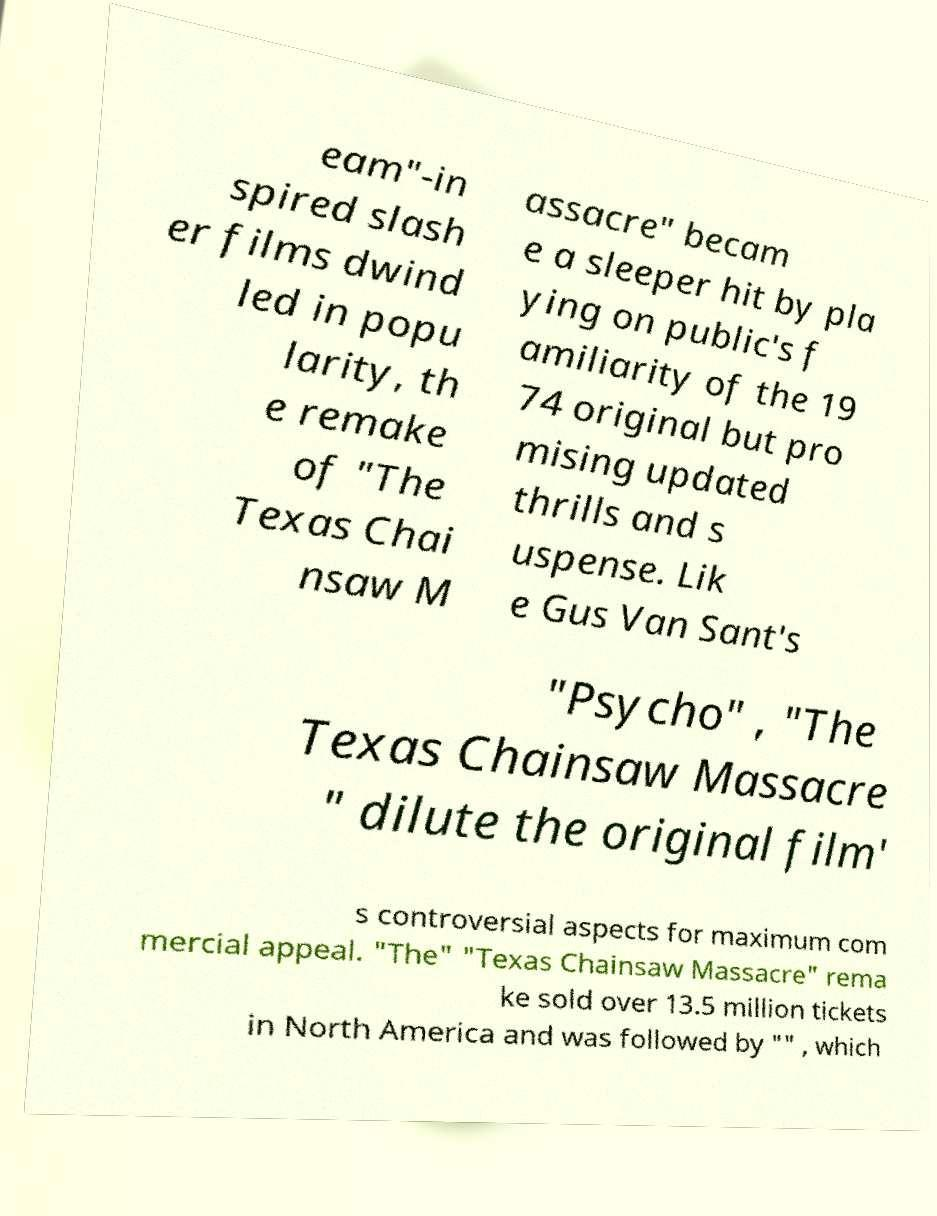I need the written content from this picture converted into text. Can you do that? eam"-in spired slash er films dwind led in popu larity, th e remake of "The Texas Chai nsaw M assacre" becam e a sleeper hit by pla ying on public's f amiliarity of the 19 74 original but pro mising updated thrills and s uspense. Lik e Gus Van Sant's "Psycho" , "The Texas Chainsaw Massacre " dilute the original film' s controversial aspects for maximum com mercial appeal. "The" "Texas Chainsaw Massacre" rema ke sold over 13.5 million tickets in North America and was followed by "" , which 